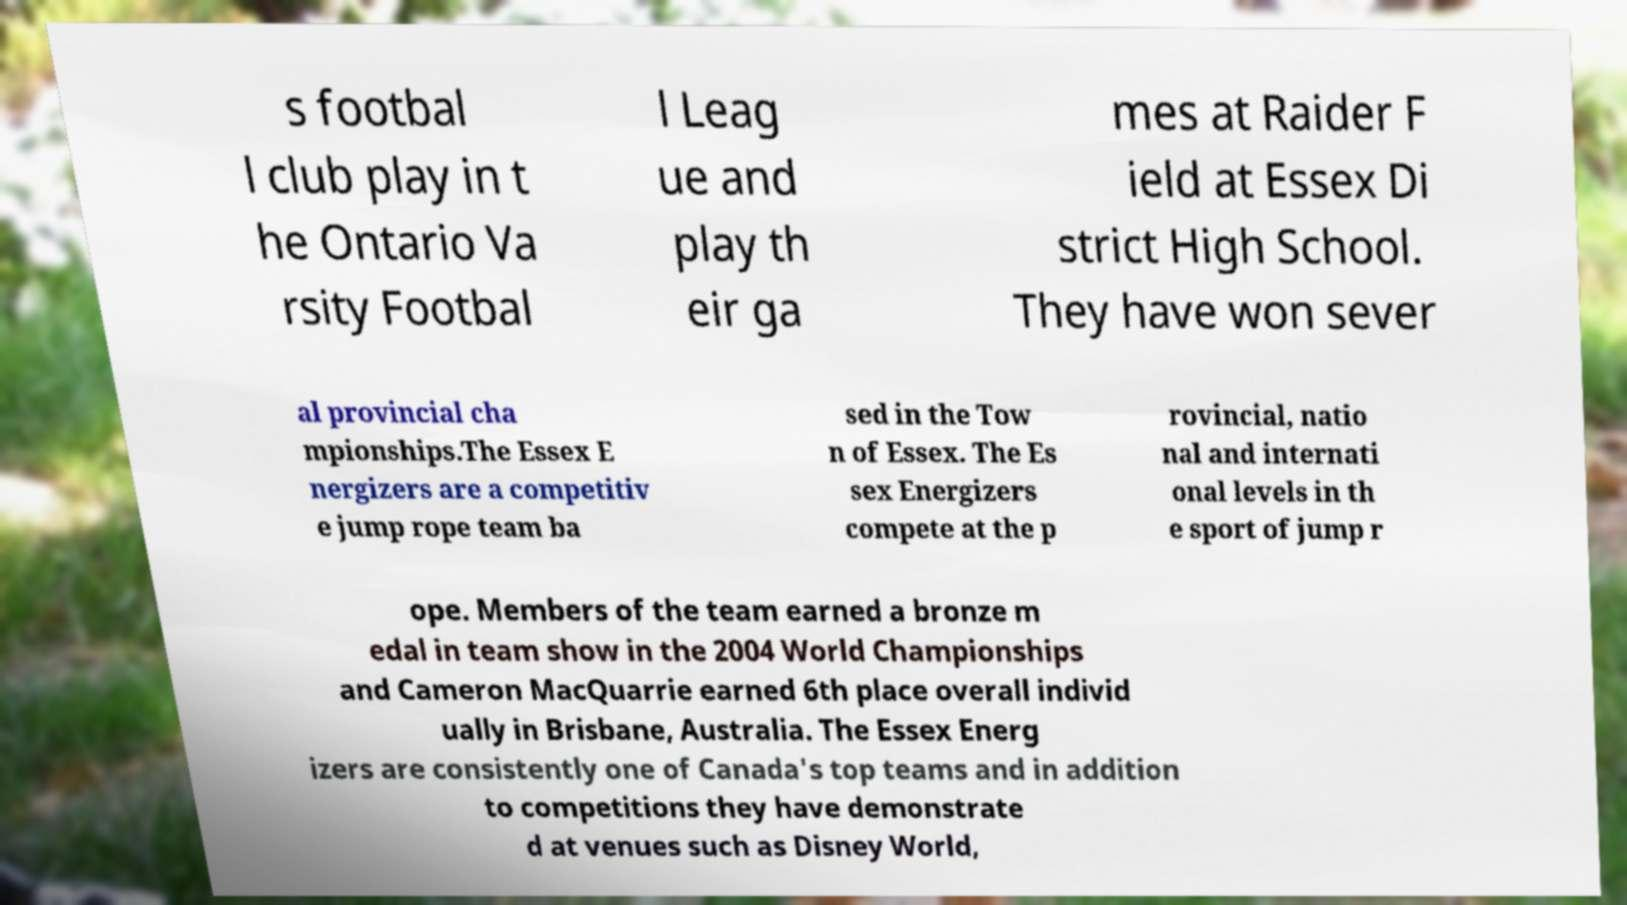Please read and relay the text visible in this image. What does it say? s footbal l club play in t he Ontario Va rsity Footbal l Leag ue and play th eir ga mes at Raider F ield at Essex Di strict High School. They have won sever al provincial cha mpionships.The Essex E nergizers are a competitiv e jump rope team ba sed in the Tow n of Essex. The Es sex Energizers compete at the p rovincial, natio nal and internati onal levels in th e sport of jump r ope. Members of the team earned a bronze m edal in team show in the 2004 World Championships and Cameron MacQuarrie earned 6th place overall individ ually in Brisbane, Australia. The Essex Energ izers are consistently one of Canada's top teams and in addition to competitions they have demonstrate d at venues such as Disney World, 